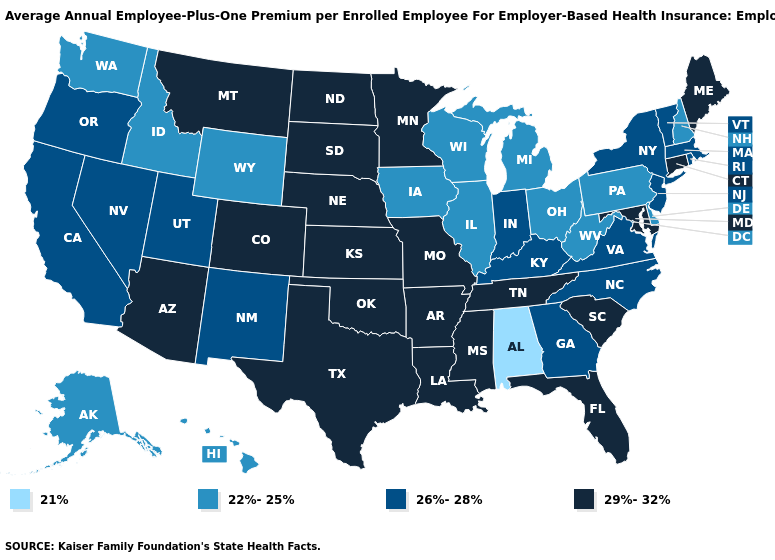Name the states that have a value in the range 26%-28%?
Short answer required. California, Georgia, Indiana, Kentucky, Massachusetts, Nevada, New Jersey, New Mexico, New York, North Carolina, Oregon, Rhode Island, Utah, Vermont, Virginia. What is the value of Pennsylvania?
Give a very brief answer. 22%-25%. What is the value of Arizona?
Short answer required. 29%-32%. Among the states that border Louisiana , which have the lowest value?
Answer briefly. Arkansas, Mississippi, Texas. Does Kentucky have a higher value than New Hampshire?
Concise answer only. Yes. Does Washington have the lowest value in the USA?
Write a very short answer. No. How many symbols are there in the legend?
Short answer required. 4. What is the lowest value in the Northeast?
Short answer required. 22%-25%. Name the states that have a value in the range 22%-25%?
Be succinct. Alaska, Delaware, Hawaii, Idaho, Illinois, Iowa, Michigan, New Hampshire, Ohio, Pennsylvania, Washington, West Virginia, Wisconsin, Wyoming. Which states have the lowest value in the West?
Give a very brief answer. Alaska, Hawaii, Idaho, Washington, Wyoming. What is the value of Indiana?
Be succinct. 26%-28%. Does Pennsylvania have the same value as New Hampshire?
Answer briefly. Yes. Does Idaho have a lower value than California?
Write a very short answer. Yes. Which states have the highest value in the USA?
Keep it brief. Arizona, Arkansas, Colorado, Connecticut, Florida, Kansas, Louisiana, Maine, Maryland, Minnesota, Mississippi, Missouri, Montana, Nebraska, North Dakota, Oklahoma, South Carolina, South Dakota, Tennessee, Texas. What is the lowest value in states that border Ohio?
Short answer required. 22%-25%. 